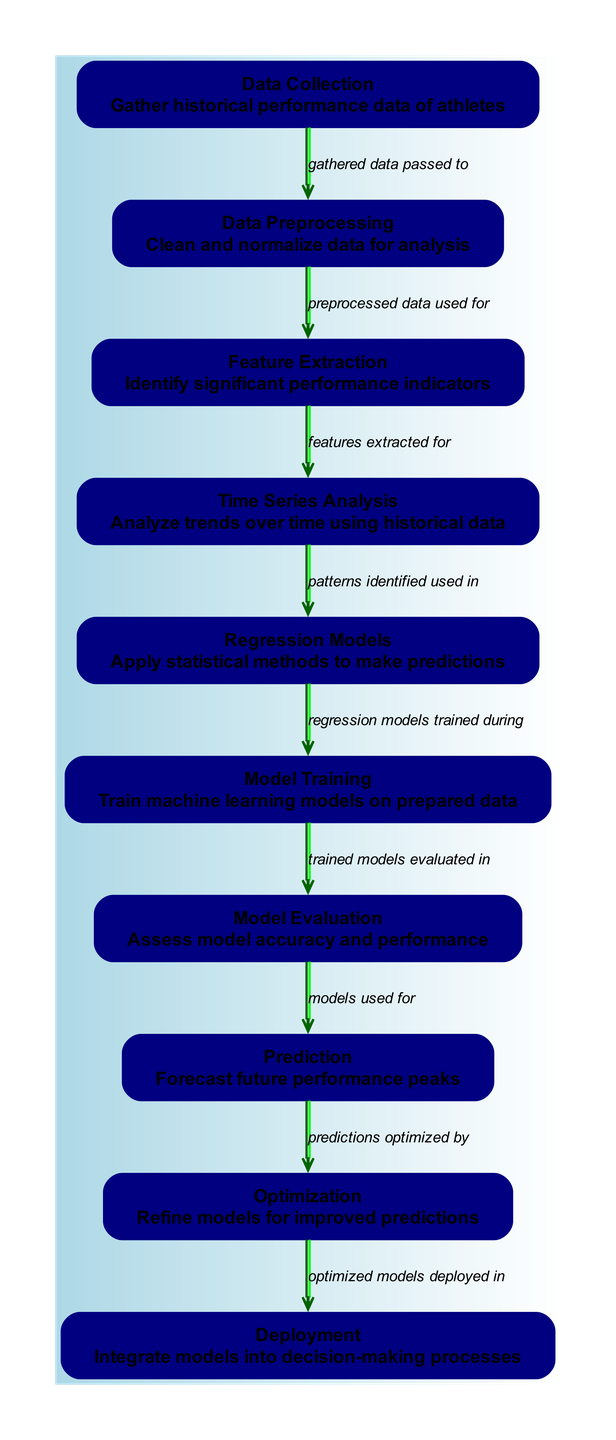What is the total number of nodes in the diagram? The diagram lists out ten distinct nodes, each representing a step or component in the machine learning process for predicting peak athletic performance.
Answer: 10 What does the "Model Evaluation" node do? The "Model Evaluation" node assesses model accuracy and performance, indicating its critical role in verifying how well the model predicts before using it for actual forecasting.
Answer: Assess model accuracy and performance Which node comes after "Time Series Analysis"? The diagram shows that after "Time Series Analysis," the next node is "Regression Models," signifying the sequence of steps in the prediction process.
Answer: Regression Models What is the function of the "Optimization" node? The "Optimization" node refines models for improved predictions, which indicates its purpose in enhancing the model's accuracy and predictive capabilities.
Answer: Refine models for improved predictions How many edges connect "Data Collection" to "Data Preprocessing"? There is a single edge connecting "Data Collection" to "Data Preprocessing," representing that the gathered data is passed to the next step of cleaning and normalizing.
Answer: 1 Which node precedes the "Prediction" node? The "Model Evaluation" node is positioned right before the "Prediction" node, showing that models must be assessed for accuracy before making predictions.
Answer: Model Evaluation What is the relationship between "Prediction" and "Optimization"? The diagram indicates that the predictions made in the "Prediction" node are optimized by the "Optimization" node, reflecting the iterative nature of machine learning model improvement.
Answer: Predictions optimized by What is the output format of the diagram? The diagram’s edges represent actions or processes that flow from one node to the next, visually illustrating how data moves and is transformed throughout the machine learning framework.
Answer: Directed graph How is "Data Preprocessing" related to "Feature Extraction"? There is an edge connecting "Data Preprocessing" to "Feature Extraction," showing that the clean and normalized data from preprocessing is utilized in extracting significant performance indicators.
Answer: Preprocessed data used for What is the main output of the overall process represented in the diagram? The final output of the entire process shown in the diagram is the "Deployment" node, which signifies the integration of optimized models into decision-making processes for predicting athletes' performances.
Answer: Integrate models into decision-making processes 